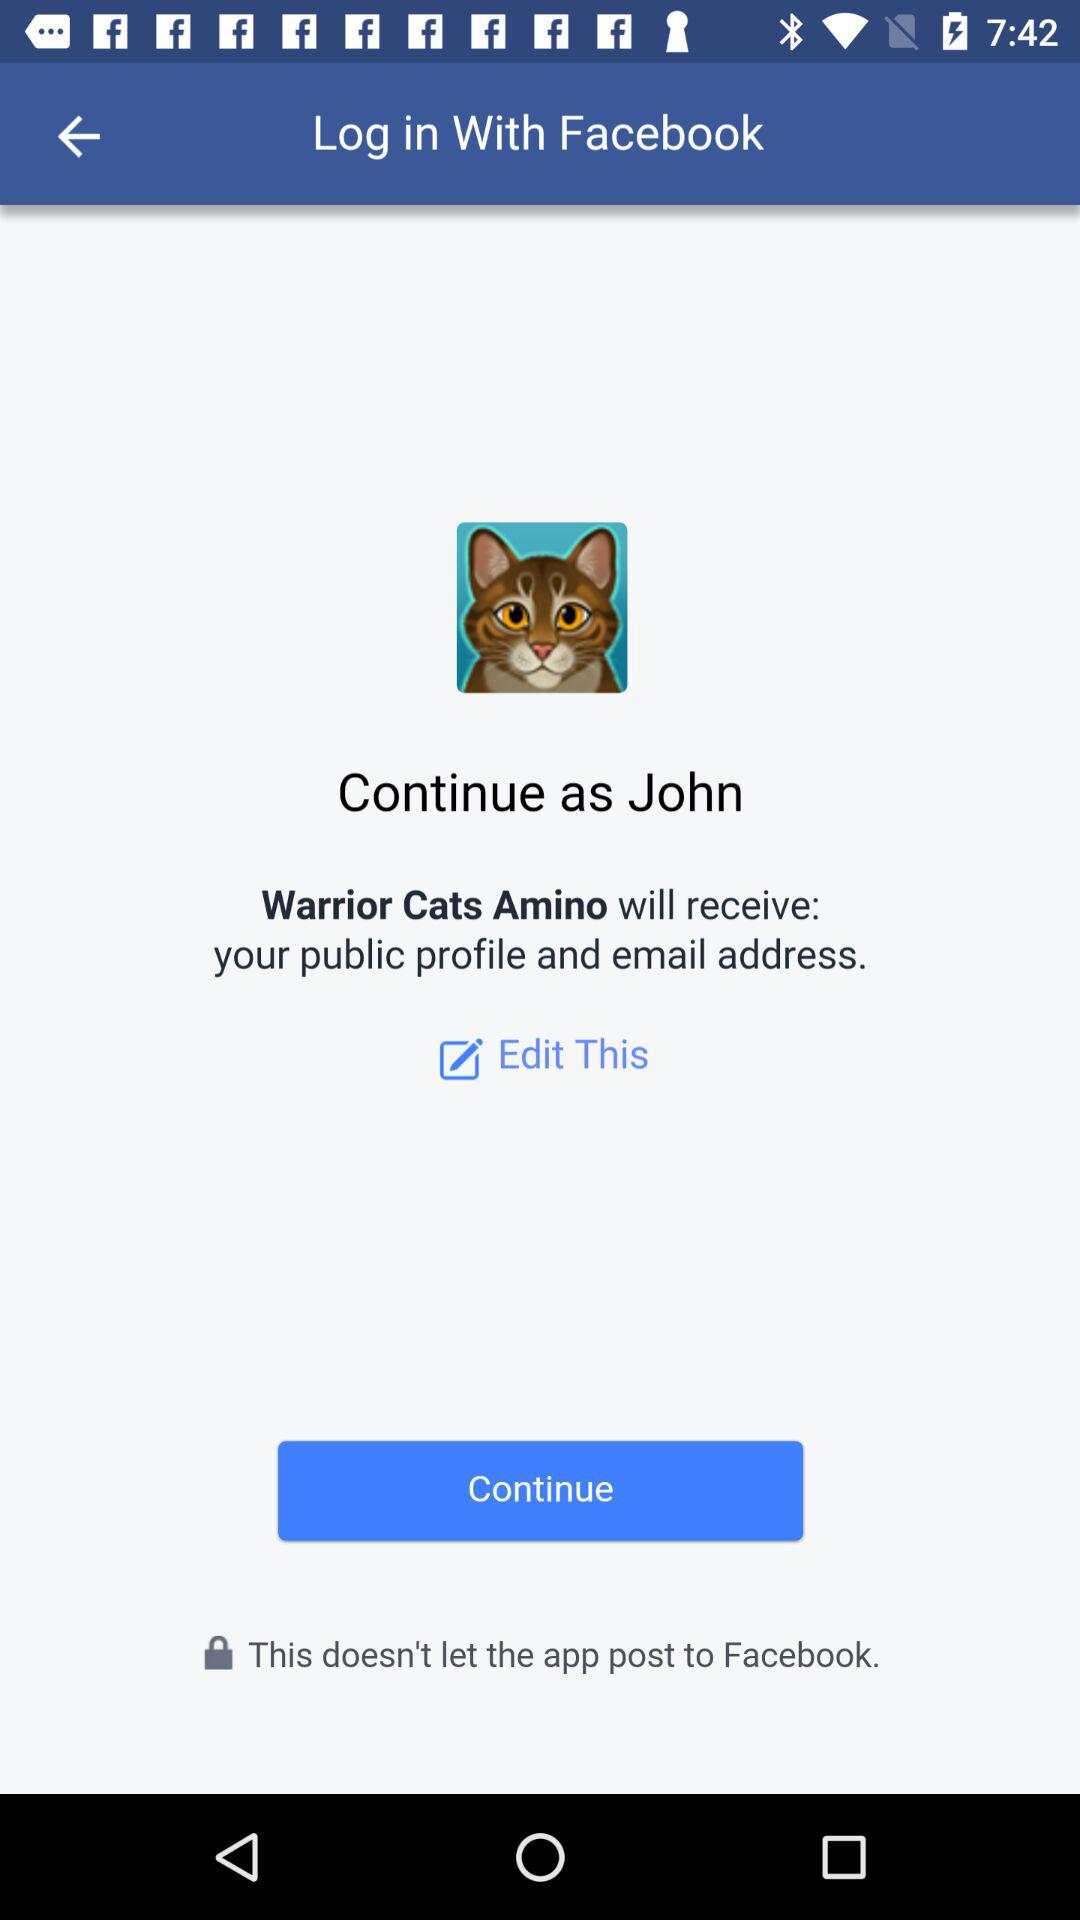What application is asking for permission? The application is "Warrior Cats Amino". 